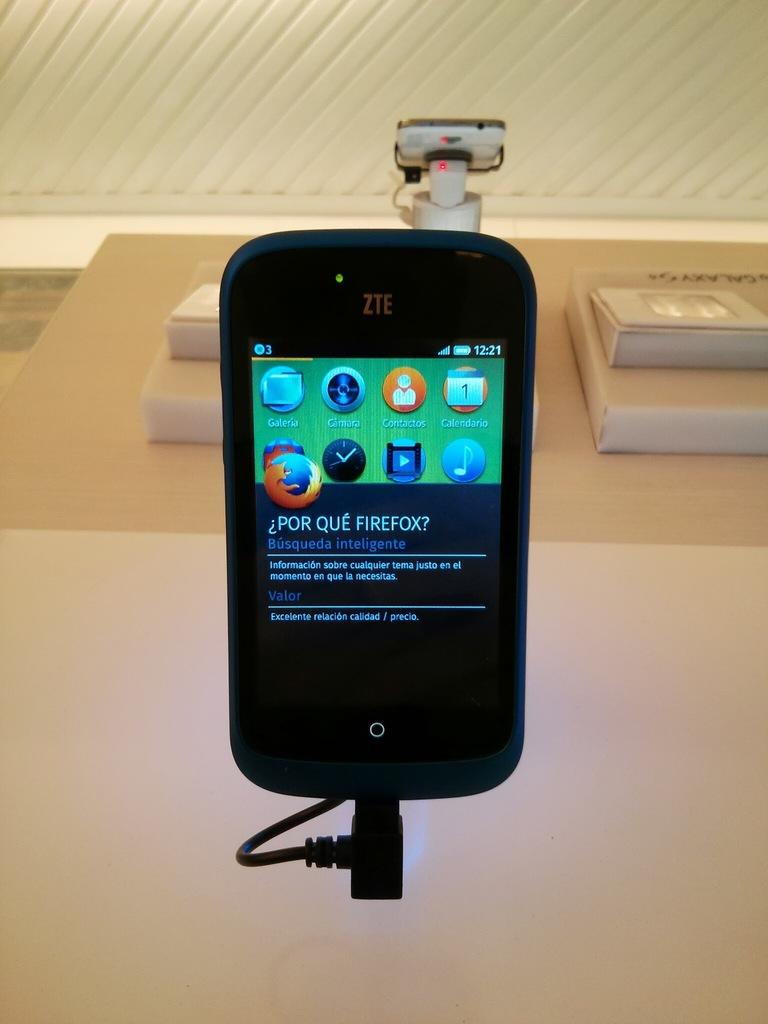Provide a one-sentence caption for the provided image. a cellphone showing in the screen why use firefox as the main browser. 